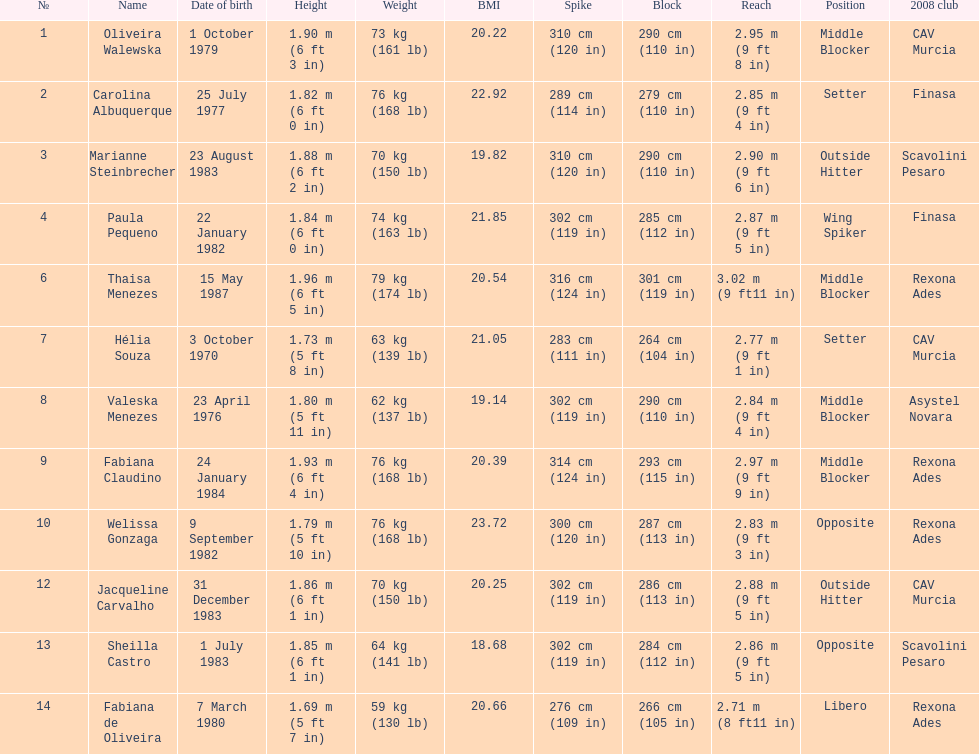Which player is the shortest at only 5 ft 7 in? Fabiana de Oliveira. 